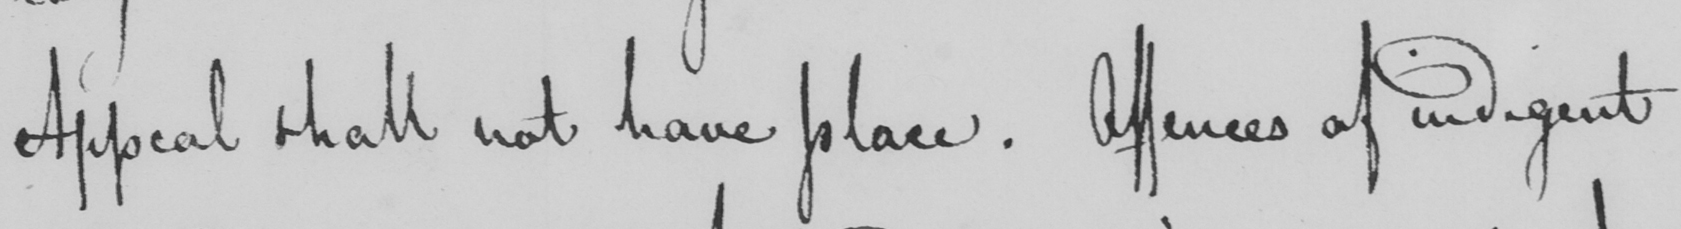What text is written in this handwritten line? Appeal shall not have place. Offences of indigent 